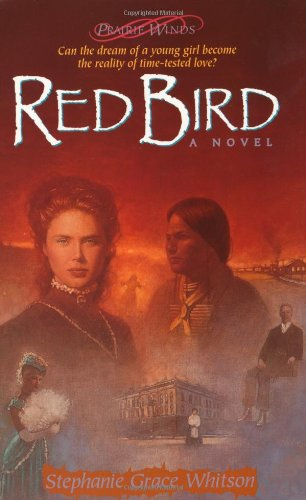Does the novel feature any notable historical figures? While 'Red Bird' does not specifically feature real historical figures, it incorporates the types of characters typical in the settling of America which enhances the historical realism. 